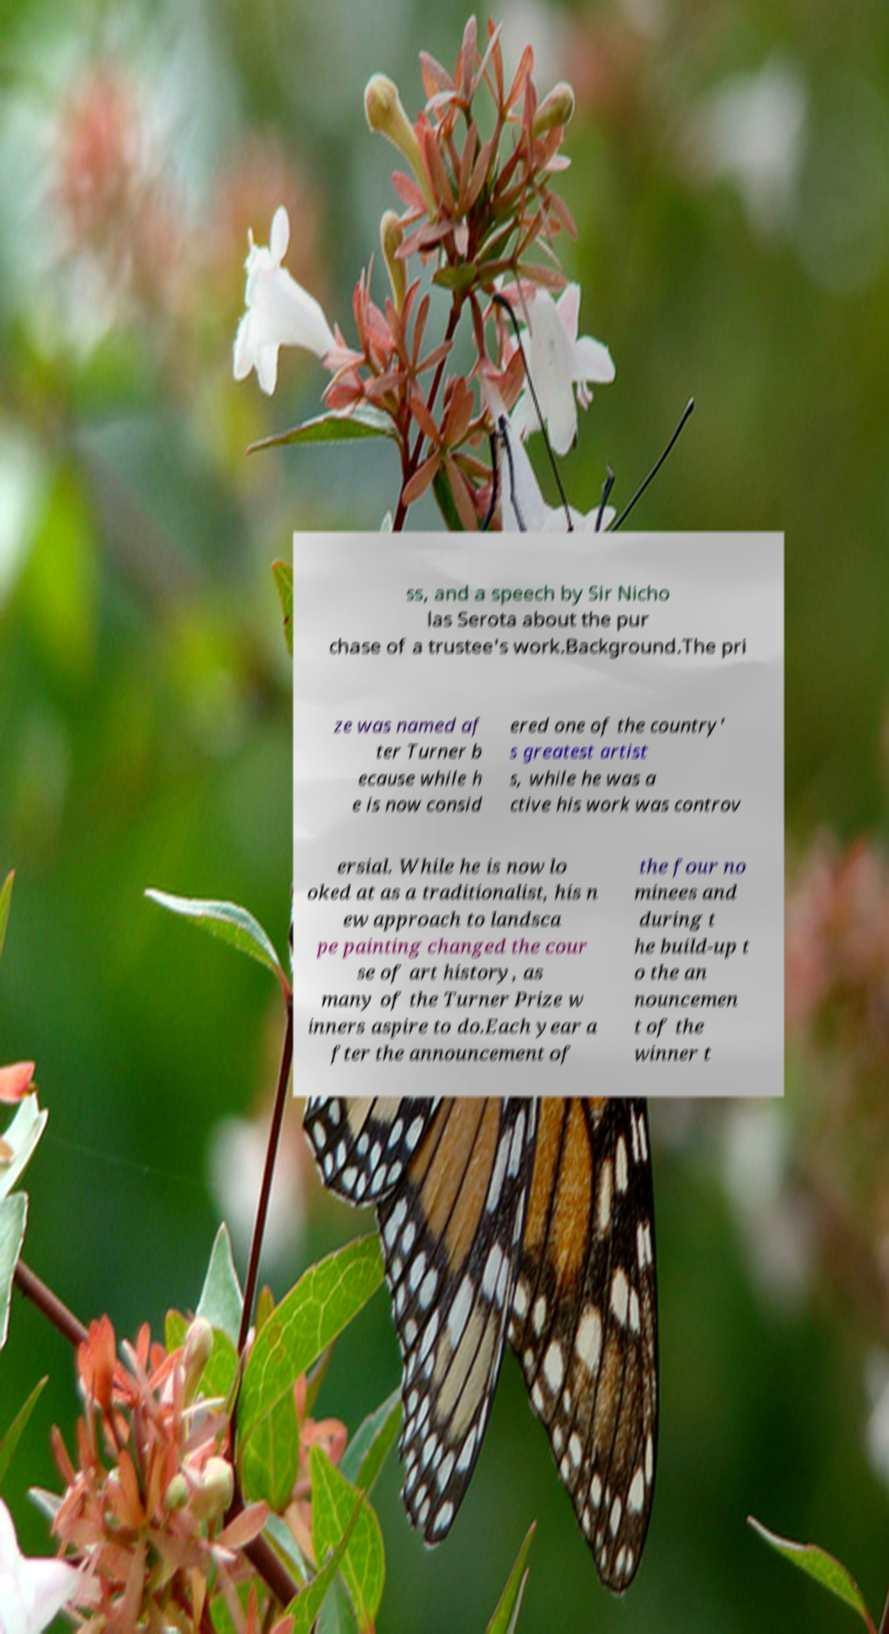There's text embedded in this image that I need extracted. Can you transcribe it verbatim? ss, and a speech by Sir Nicho las Serota about the pur chase of a trustee's work.Background.The pri ze was named af ter Turner b ecause while h e is now consid ered one of the country' s greatest artist s, while he was a ctive his work was controv ersial. While he is now lo oked at as a traditionalist, his n ew approach to landsca pe painting changed the cour se of art history, as many of the Turner Prize w inners aspire to do.Each year a fter the announcement of the four no minees and during t he build-up t o the an nouncemen t of the winner t 